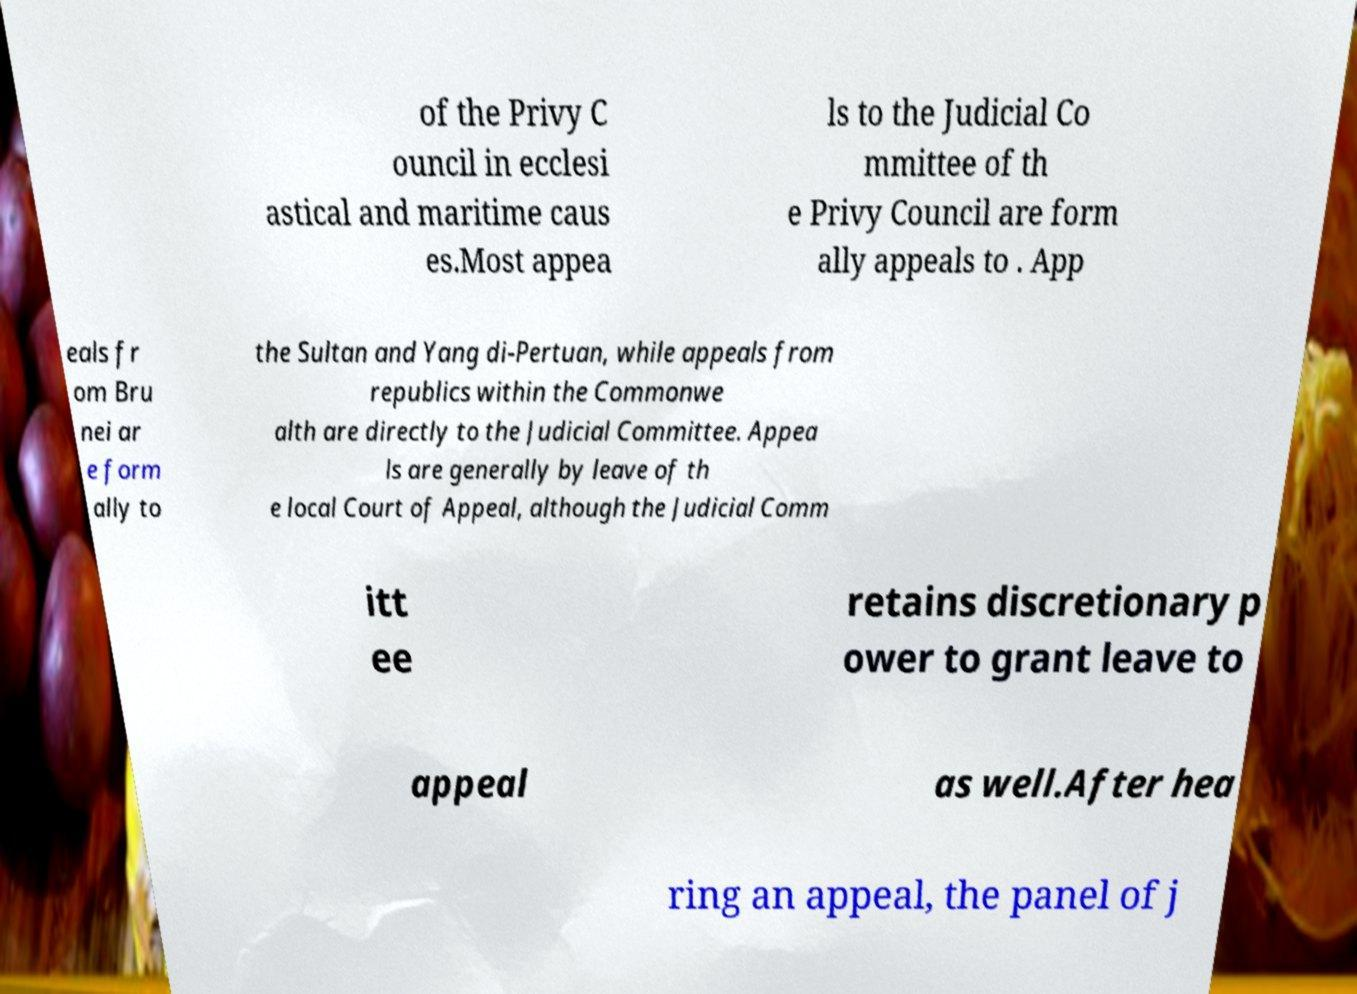Could you extract and type out the text from this image? of the Privy C ouncil in ecclesi astical and maritime caus es.Most appea ls to the Judicial Co mmittee of th e Privy Council are form ally appeals to . App eals fr om Bru nei ar e form ally to the Sultan and Yang di-Pertuan, while appeals from republics within the Commonwe alth are directly to the Judicial Committee. Appea ls are generally by leave of th e local Court of Appeal, although the Judicial Comm itt ee retains discretionary p ower to grant leave to appeal as well.After hea ring an appeal, the panel of j 